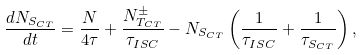<formula> <loc_0><loc_0><loc_500><loc_500>\frac { d N _ { S _ { C T } } } { d t } = \frac { N } { 4 \tau } + \frac { N _ { T _ { C T } } ^ { \pm } } { \tau _ { I S C } } - N _ { S _ { C T } } \left ( \frac { 1 } { \tau _ { I S C } } + \frac { 1 } { \tau _ { S _ { C T } } } \right ) ,</formula> 